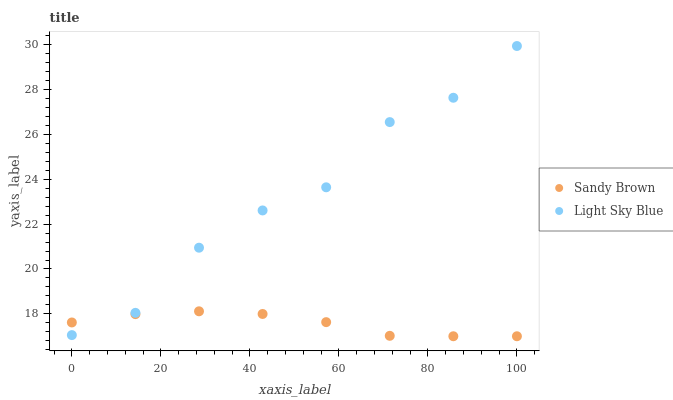Does Sandy Brown have the minimum area under the curve?
Answer yes or no. Yes. Does Light Sky Blue have the maximum area under the curve?
Answer yes or no. Yes. Does Sandy Brown have the maximum area under the curve?
Answer yes or no. No. Is Sandy Brown the smoothest?
Answer yes or no. Yes. Is Light Sky Blue the roughest?
Answer yes or no. Yes. Is Sandy Brown the roughest?
Answer yes or no. No. Does Sandy Brown have the lowest value?
Answer yes or no. Yes. Does Light Sky Blue have the highest value?
Answer yes or no. Yes. Does Sandy Brown have the highest value?
Answer yes or no. No. Does Light Sky Blue intersect Sandy Brown?
Answer yes or no. Yes. Is Light Sky Blue less than Sandy Brown?
Answer yes or no. No. Is Light Sky Blue greater than Sandy Brown?
Answer yes or no. No. 